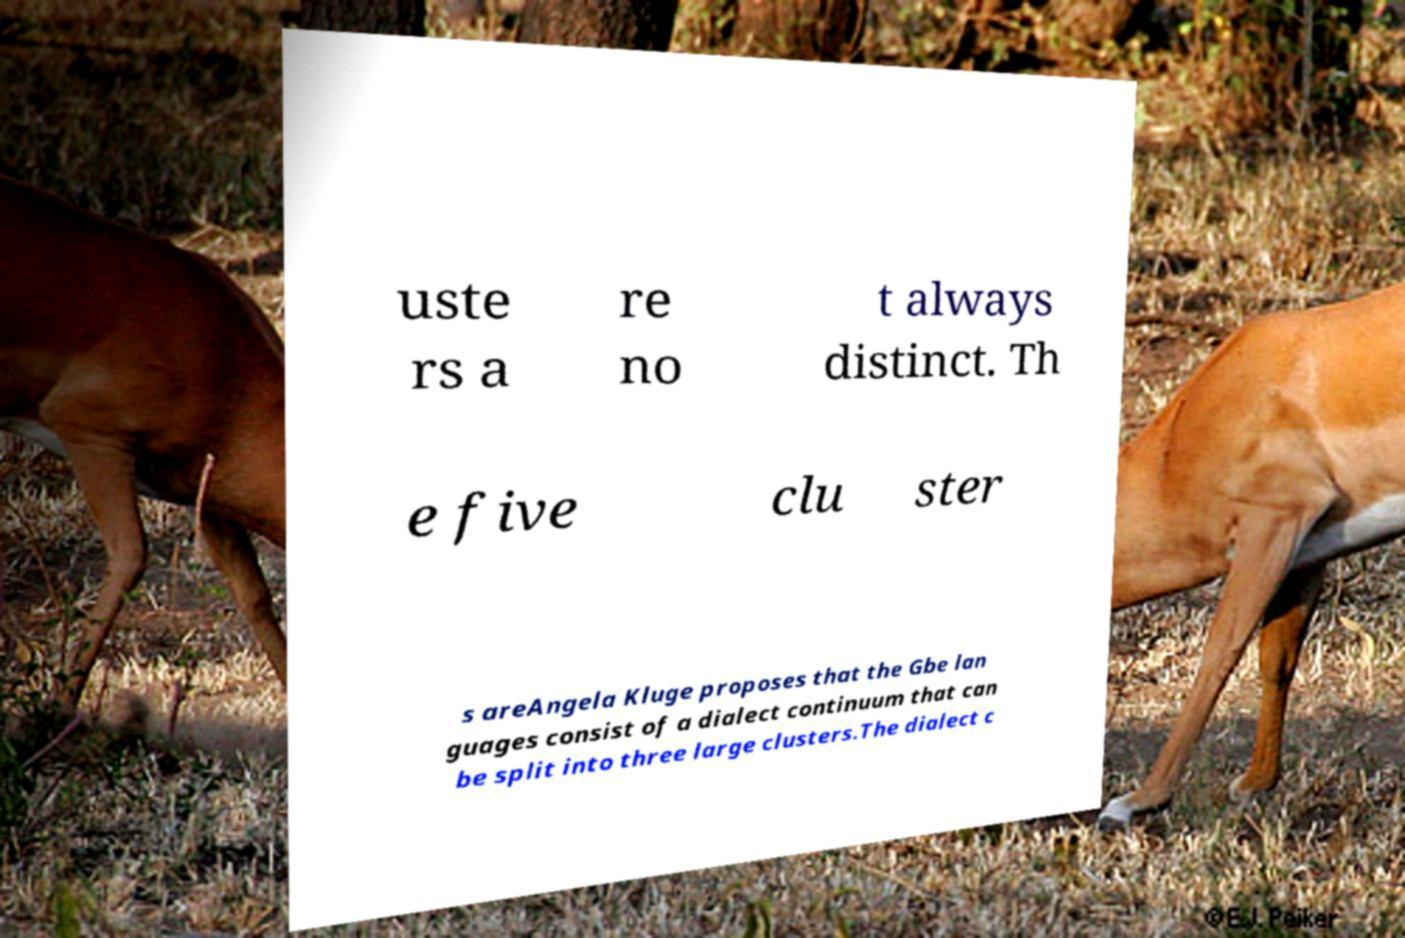There's text embedded in this image that I need extracted. Can you transcribe it verbatim? uste rs a re no t always distinct. Th e five clu ster s areAngela Kluge proposes that the Gbe lan guages consist of a dialect continuum that can be split into three large clusters.The dialect c 